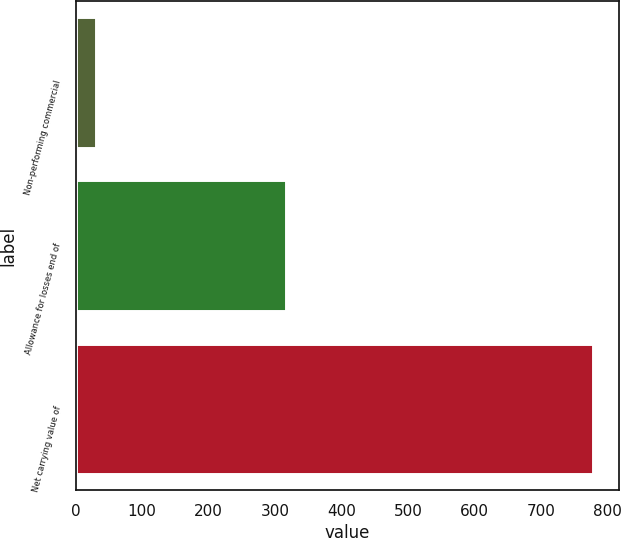Convert chart to OTSL. <chart><loc_0><loc_0><loc_500><loc_500><bar_chart><fcel>Non-performing commercial<fcel>Allowance for losses end of<fcel>Net carrying value of<nl><fcel>30<fcel>316<fcel>778<nl></chart> 